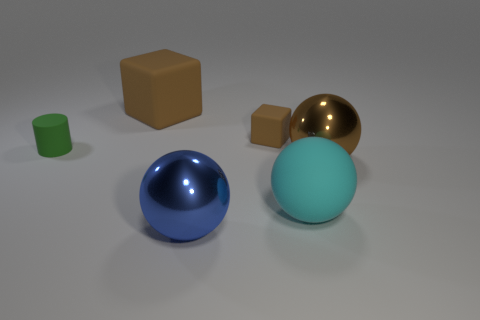How many objects are present in the image, and what are their colors? There are six objects in the image, each with a unique or distinct color: a tan cube, a small brown cube, a green cylinder, a glossy gold sphere, a glossy blue sphere, and a large matte cyan sphere. 